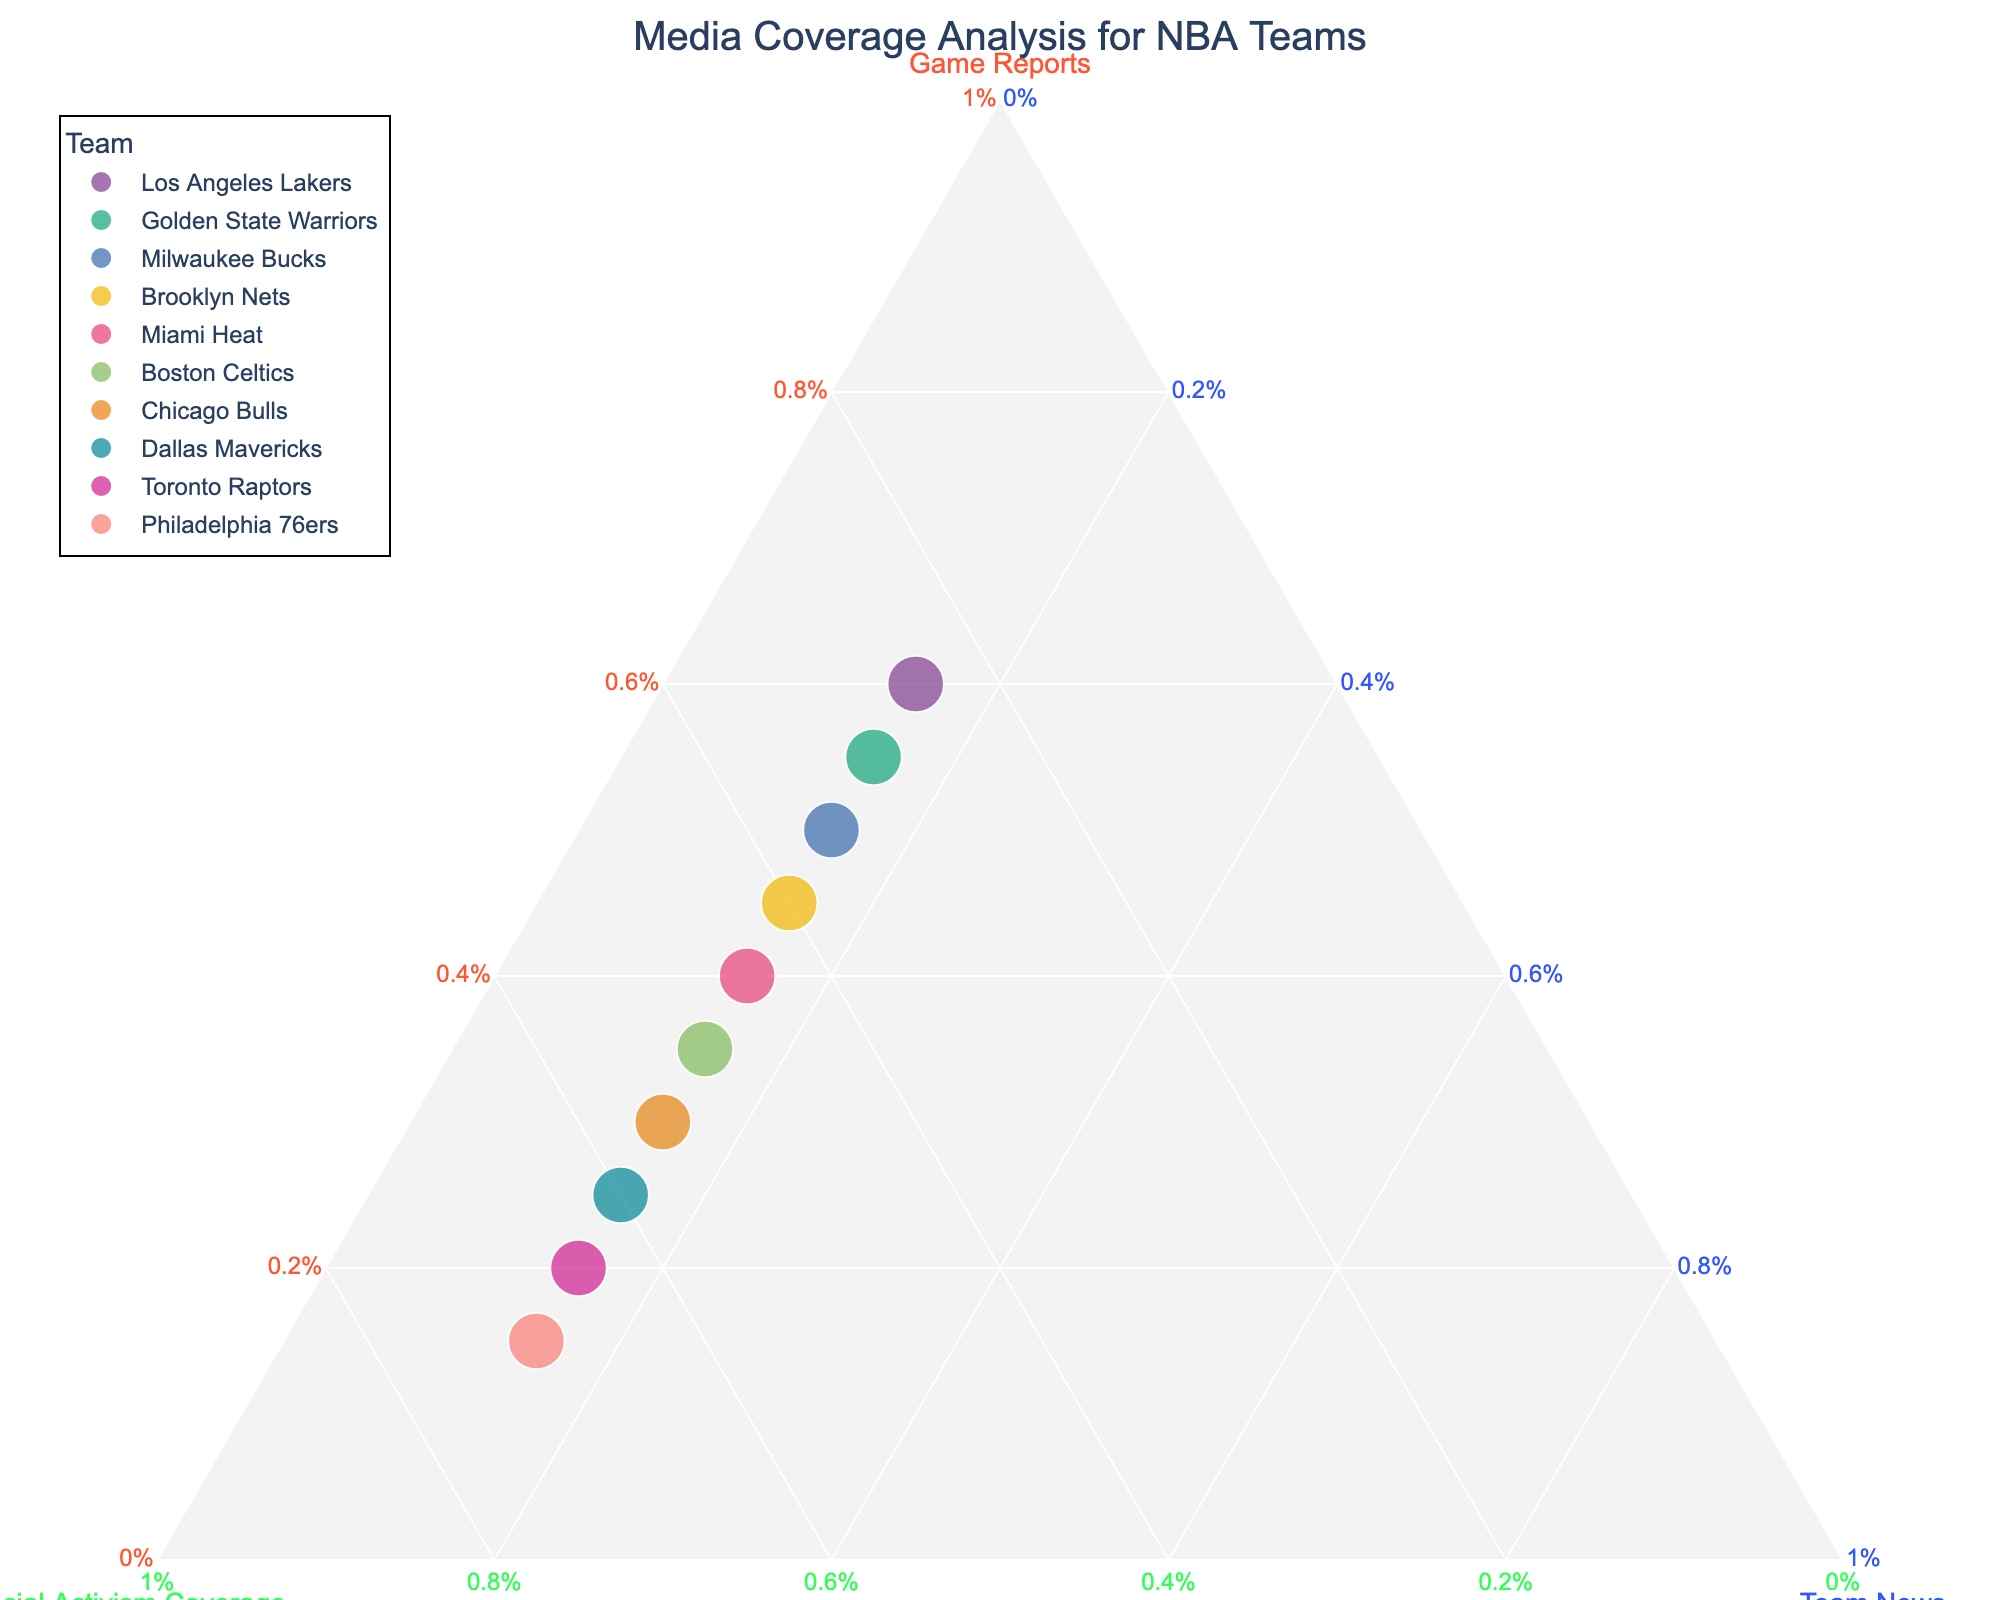How many teams are represented in the plot? Count the number of unique teams displayed in the plot.
Answer: 10 Which team has the highest percentage of social activism coverage? Look at the vertical axis labeled "Social Activism Coverage" and identify the team with the highest position on this axis.
Answer: Philadelphia 76ers How does the media coverage of Game Reports compare between the Los Angeles Lakers and Chicago Bulls? Identify the positions of "Game Reports" for both teams on the corresponding axis and compare them. Los Angeles Lakers are at 60% and Chicago Bulls are at 30%.
Answer: Los Angeles Lakers' Game Reports coverage is higher Which team has the smallest percentage allocated to Game Reports? Look along the axis labeled "Game Reports" and find the team with the lowest value.
Answer: Philadelphia 76ers What is the combined percentage of Social Activism Coverage for the Miami Heat and the Brooklyn Nets? Add the percentages of Social Activism Coverage for both teams, which are 45% and 40%.
Answer: 85% Is there any team with equal percentages of Social Activism Coverage and Team News? Check to see if any points align such that the values of Social Activism Coverage and Team News are the same. All values for Team News are 15%, but Social Activism Coverage varies.
Answer: No Which team shows a balanced coverage of Game Reports, Social Activism Coverage, and Team News? Look for the point closest to the center of the triangle, indicating balanced coverage. This is when each proportion is near 33.3%, but in this dataset, coverage is less balanced.
Answer: None Between Boston Celtics and Golden State Warriors, which team has a higher focus on Social Activism Coverage? Compare the Social Activism Coverage percentages of Boston Celtics (50%) and Golden State Warriors (30%).
Answer: Boston Celtics If we consider Game Reports and Social Activism Coverage as equally important, which team has the highest combined percentage in these categories? Add the percentages for "Game Reports" and "Social Activism Coverage" for each team and find the highest individual amount. Philadelphia 76ers have 15% + 70% = 85%.
Answer: Philadelphia 76ers How much more is the Social Activism Coverage of the Toronto Raptors compared to Game Reports? Subtract the Game Reports percentage from the Social Activism Coverage percentage for the Toronto Raptors: 65% - 20%.
Answer: 45% 